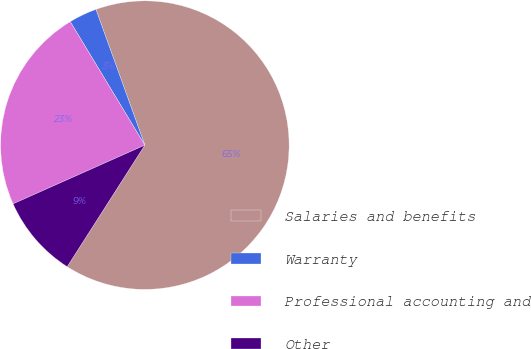Convert chart. <chart><loc_0><loc_0><loc_500><loc_500><pie_chart><fcel>Salaries and benefits<fcel>Warranty<fcel>Professional accounting and<fcel>Other<nl><fcel>64.55%<fcel>3.14%<fcel>23.02%<fcel>9.28%<nl></chart> 